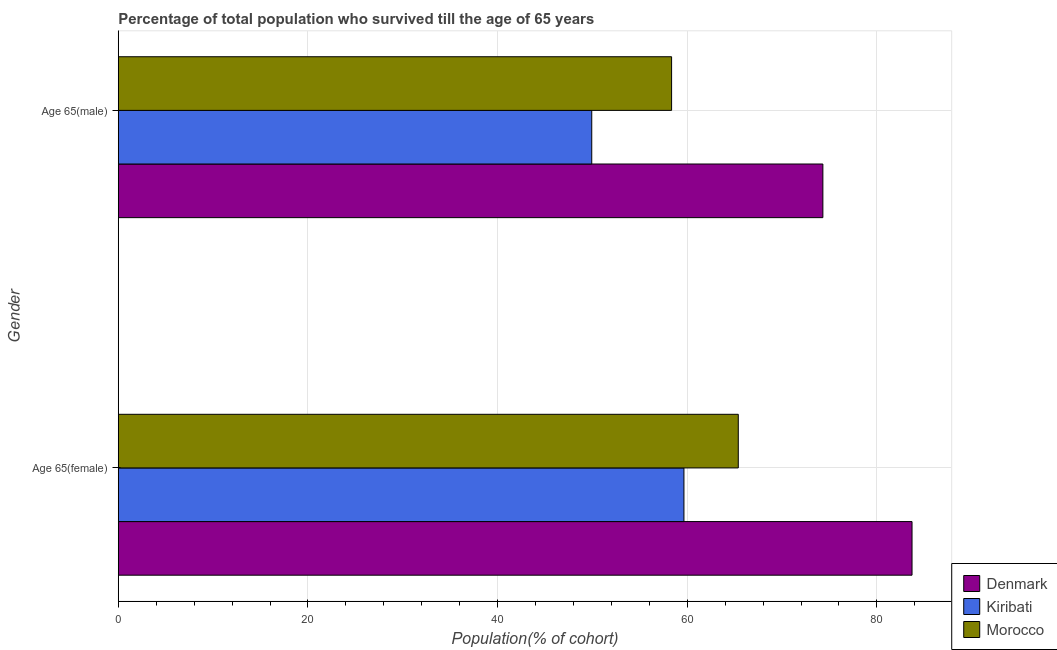How many different coloured bars are there?
Your answer should be very brief. 3. Are the number of bars per tick equal to the number of legend labels?
Offer a very short reply. Yes. What is the label of the 2nd group of bars from the top?
Offer a terse response. Age 65(female). What is the percentage of male population who survived till age of 65 in Denmark?
Ensure brevity in your answer.  74.3. Across all countries, what is the maximum percentage of male population who survived till age of 65?
Your response must be concise. 74.3. Across all countries, what is the minimum percentage of female population who survived till age of 65?
Provide a short and direct response. 59.65. In which country was the percentage of male population who survived till age of 65 maximum?
Offer a terse response. Denmark. In which country was the percentage of female population who survived till age of 65 minimum?
Offer a terse response. Kiribati. What is the total percentage of female population who survived till age of 65 in the graph?
Provide a succinct answer. 208.74. What is the difference between the percentage of female population who survived till age of 65 in Denmark and that in Kiribati?
Your answer should be compact. 24.05. What is the difference between the percentage of male population who survived till age of 65 in Denmark and the percentage of female population who survived till age of 65 in Morocco?
Your answer should be compact. 8.92. What is the average percentage of female population who survived till age of 65 per country?
Provide a succinct answer. 69.58. What is the difference between the percentage of female population who survived till age of 65 and percentage of male population who survived till age of 65 in Morocco?
Offer a terse response. 7.03. What is the ratio of the percentage of female population who survived till age of 65 in Kiribati to that in Morocco?
Provide a succinct answer. 0.91. Is the percentage of male population who survived till age of 65 in Morocco less than that in Denmark?
Provide a short and direct response. Yes. In how many countries, is the percentage of female population who survived till age of 65 greater than the average percentage of female population who survived till age of 65 taken over all countries?
Make the answer very short. 1. What does the 1st bar from the top in Age 65(female) represents?
Keep it short and to the point. Morocco. What does the 2nd bar from the bottom in Age 65(female) represents?
Make the answer very short. Kiribati. How many bars are there?
Your answer should be very brief. 6. Are all the bars in the graph horizontal?
Make the answer very short. Yes. What is the difference between two consecutive major ticks on the X-axis?
Offer a very short reply. 20. Are the values on the major ticks of X-axis written in scientific E-notation?
Your answer should be compact. No. Does the graph contain any zero values?
Give a very brief answer. No. Where does the legend appear in the graph?
Make the answer very short. Bottom right. What is the title of the graph?
Provide a short and direct response. Percentage of total population who survived till the age of 65 years. What is the label or title of the X-axis?
Offer a very short reply. Population(% of cohort). What is the label or title of the Y-axis?
Your answer should be compact. Gender. What is the Population(% of cohort) of Denmark in Age 65(female)?
Your response must be concise. 83.71. What is the Population(% of cohort) in Kiribati in Age 65(female)?
Make the answer very short. 59.65. What is the Population(% of cohort) of Morocco in Age 65(female)?
Offer a terse response. 65.38. What is the Population(% of cohort) in Denmark in Age 65(male)?
Offer a terse response. 74.3. What is the Population(% of cohort) in Kiribati in Age 65(male)?
Ensure brevity in your answer.  49.93. What is the Population(% of cohort) in Morocco in Age 65(male)?
Offer a terse response. 58.35. Across all Gender, what is the maximum Population(% of cohort) of Denmark?
Provide a succinct answer. 83.71. Across all Gender, what is the maximum Population(% of cohort) of Kiribati?
Your response must be concise. 59.65. Across all Gender, what is the maximum Population(% of cohort) of Morocco?
Offer a very short reply. 65.38. Across all Gender, what is the minimum Population(% of cohort) in Denmark?
Ensure brevity in your answer.  74.3. Across all Gender, what is the minimum Population(% of cohort) in Kiribati?
Make the answer very short. 49.93. Across all Gender, what is the minimum Population(% of cohort) of Morocco?
Offer a terse response. 58.35. What is the total Population(% of cohort) of Denmark in the graph?
Keep it short and to the point. 158.01. What is the total Population(% of cohort) of Kiribati in the graph?
Make the answer very short. 109.58. What is the total Population(% of cohort) in Morocco in the graph?
Your answer should be very brief. 123.73. What is the difference between the Population(% of cohort) in Denmark in Age 65(female) and that in Age 65(male)?
Your answer should be compact. 9.4. What is the difference between the Population(% of cohort) in Kiribati in Age 65(female) and that in Age 65(male)?
Give a very brief answer. 9.72. What is the difference between the Population(% of cohort) of Morocco in Age 65(female) and that in Age 65(male)?
Ensure brevity in your answer.  7.03. What is the difference between the Population(% of cohort) of Denmark in Age 65(female) and the Population(% of cohort) of Kiribati in Age 65(male)?
Ensure brevity in your answer.  33.78. What is the difference between the Population(% of cohort) in Denmark in Age 65(female) and the Population(% of cohort) in Morocco in Age 65(male)?
Provide a succinct answer. 25.36. What is the difference between the Population(% of cohort) in Kiribati in Age 65(female) and the Population(% of cohort) in Morocco in Age 65(male)?
Offer a very short reply. 1.3. What is the average Population(% of cohort) of Denmark per Gender?
Give a very brief answer. 79. What is the average Population(% of cohort) in Kiribati per Gender?
Your answer should be very brief. 54.79. What is the average Population(% of cohort) in Morocco per Gender?
Give a very brief answer. 61.87. What is the difference between the Population(% of cohort) in Denmark and Population(% of cohort) in Kiribati in Age 65(female)?
Your answer should be very brief. 24.05. What is the difference between the Population(% of cohort) in Denmark and Population(% of cohort) in Morocco in Age 65(female)?
Your answer should be very brief. 18.32. What is the difference between the Population(% of cohort) in Kiribati and Population(% of cohort) in Morocco in Age 65(female)?
Give a very brief answer. -5.73. What is the difference between the Population(% of cohort) of Denmark and Population(% of cohort) of Kiribati in Age 65(male)?
Make the answer very short. 24.37. What is the difference between the Population(% of cohort) of Denmark and Population(% of cohort) of Morocco in Age 65(male)?
Offer a terse response. 15.95. What is the difference between the Population(% of cohort) of Kiribati and Population(% of cohort) of Morocco in Age 65(male)?
Your answer should be very brief. -8.42. What is the ratio of the Population(% of cohort) in Denmark in Age 65(female) to that in Age 65(male)?
Offer a very short reply. 1.13. What is the ratio of the Population(% of cohort) of Kiribati in Age 65(female) to that in Age 65(male)?
Your answer should be compact. 1.19. What is the ratio of the Population(% of cohort) of Morocco in Age 65(female) to that in Age 65(male)?
Provide a succinct answer. 1.12. What is the difference between the highest and the second highest Population(% of cohort) of Denmark?
Ensure brevity in your answer.  9.4. What is the difference between the highest and the second highest Population(% of cohort) in Kiribati?
Provide a short and direct response. 9.72. What is the difference between the highest and the second highest Population(% of cohort) of Morocco?
Give a very brief answer. 7.03. What is the difference between the highest and the lowest Population(% of cohort) in Denmark?
Offer a terse response. 9.4. What is the difference between the highest and the lowest Population(% of cohort) of Kiribati?
Provide a short and direct response. 9.72. What is the difference between the highest and the lowest Population(% of cohort) in Morocco?
Provide a succinct answer. 7.03. 